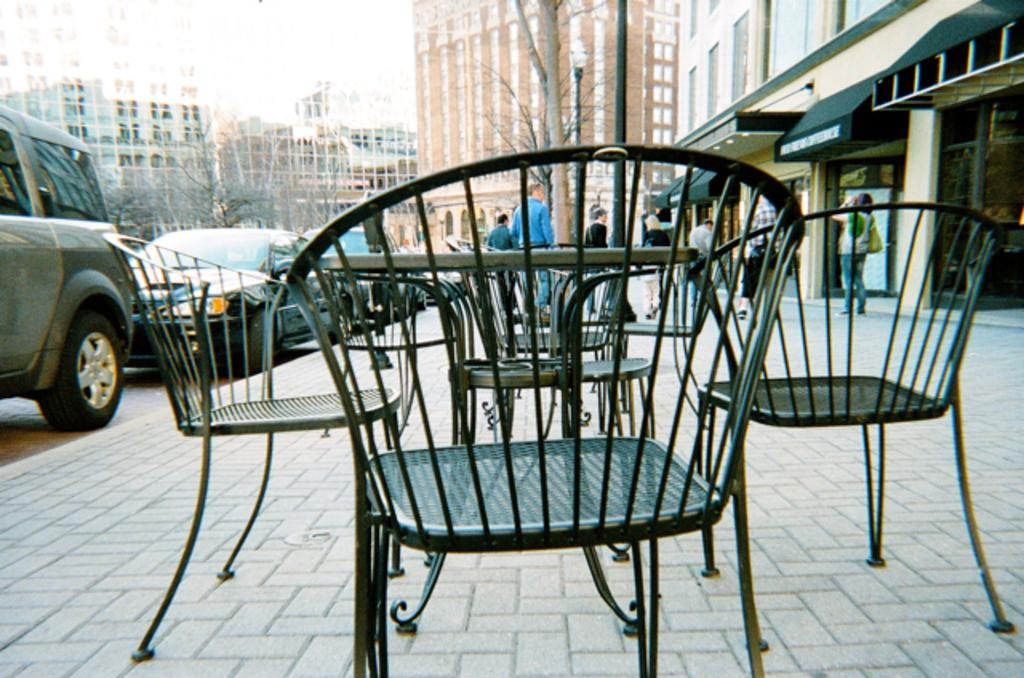What type of furniture is visible in the image? There are chairs and a table in the image. Can you describe the setting in which the furniture is located? There are people, cars, buildings, and trees visible in the background of the image. How many elements can be seen in the background of the image? There are four elements present in the background: people, cars, buildings, and trees. What time of day is depicted in the image, and how can you tell? The time of day cannot be determined from the image, as there are no specific details or clues to indicate morning or any other time. 